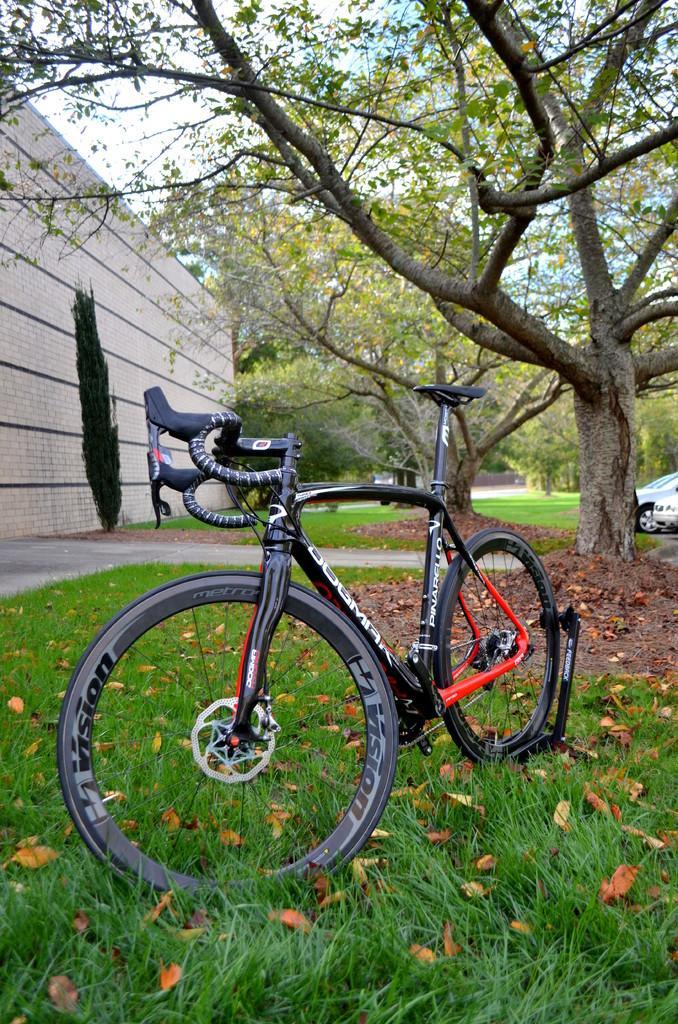Please provide a concise description of this image. In the picture we can see the grass surface with a bicycle is parked and behind it, we can see some trees and a part of the wall. 